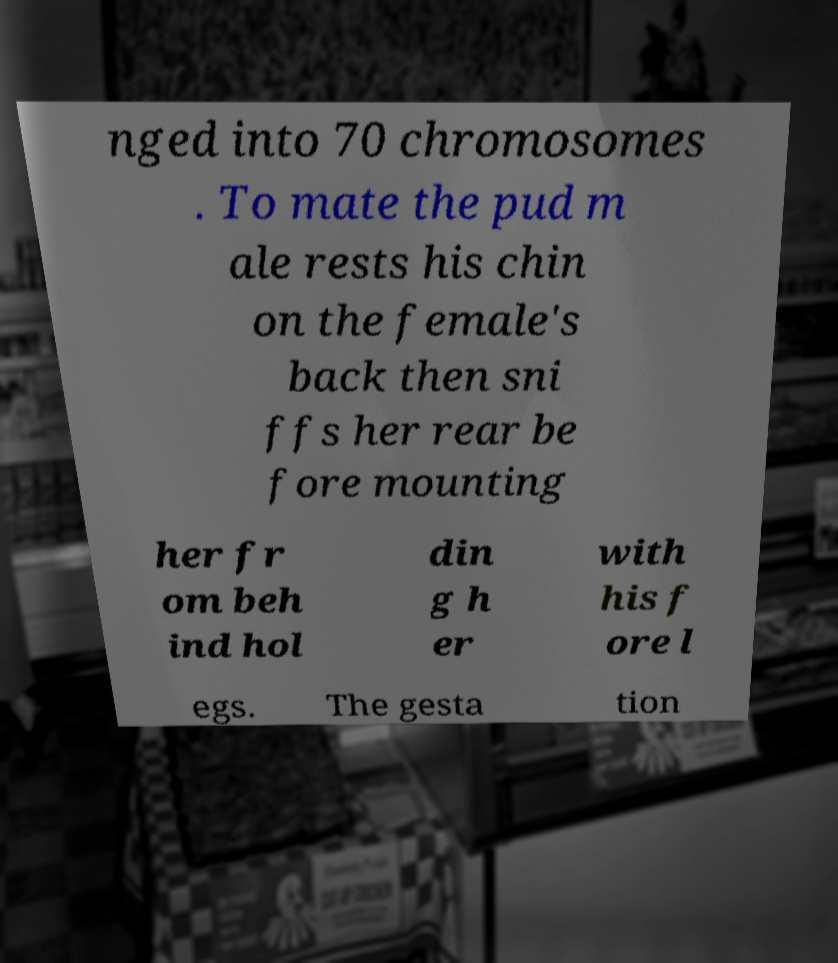Please identify and transcribe the text found in this image. nged into 70 chromosomes . To mate the pud m ale rests his chin on the female's back then sni ffs her rear be fore mounting her fr om beh ind hol din g h er with his f ore l egs. The gesta tion 